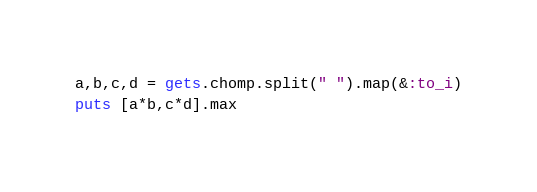Convert code to text. <code><loc_0><loc_0><loc_500><loc_500><_Ruby_>a,b,c,d = gets.chomp.split(" ").map(&:to_i)
puts [a*b,c*d].max</code> 